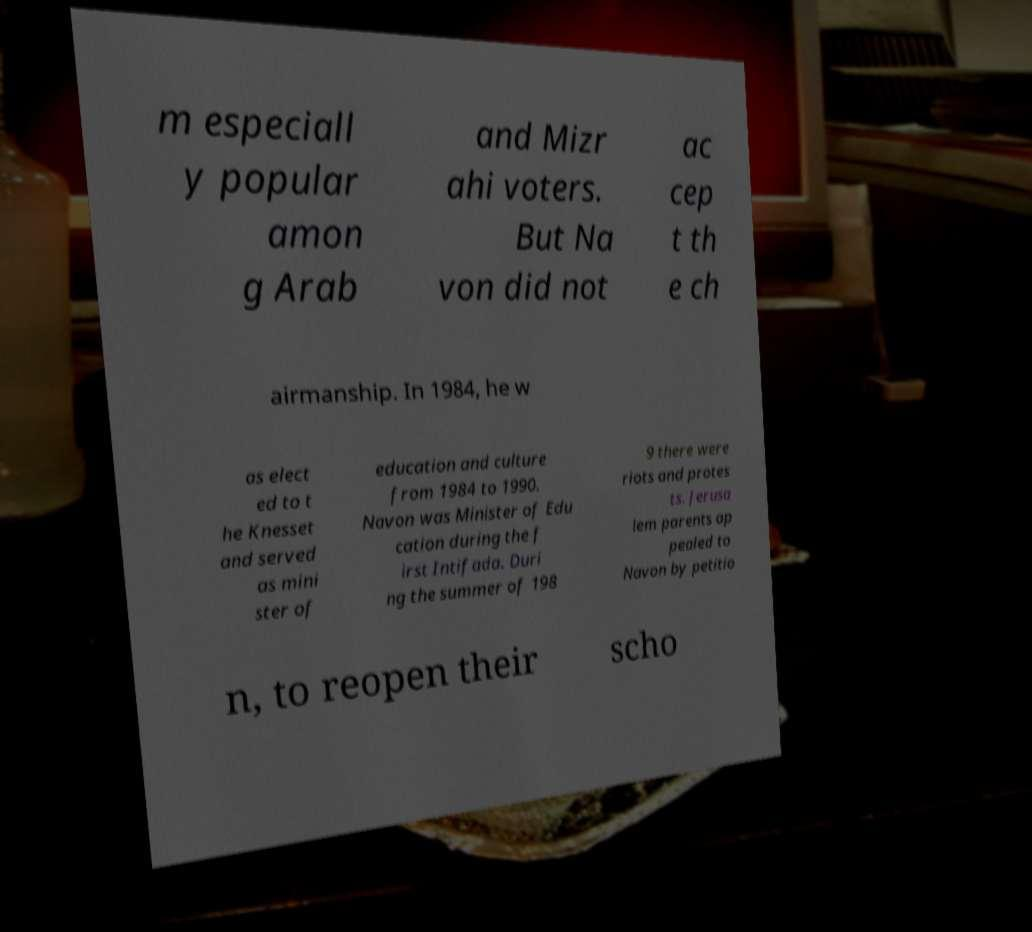Please read and relay the text visible in this image. What does it say? m especiall y popular amon g Arab and Mizr ahi voters. But Na von did not ac cep t th e ch airmanship. In 1984, he w as elect ed to t he Knesset and served as mini ster of education and culture from 1984 to 1990. Navon was Minister of Edu cation during the f irst Intifada. Duri ng the summer of 198 9 there were riots and protes ts. Jerusa lem parents ap pealed to Navon by petitio n, to reopen their scho 